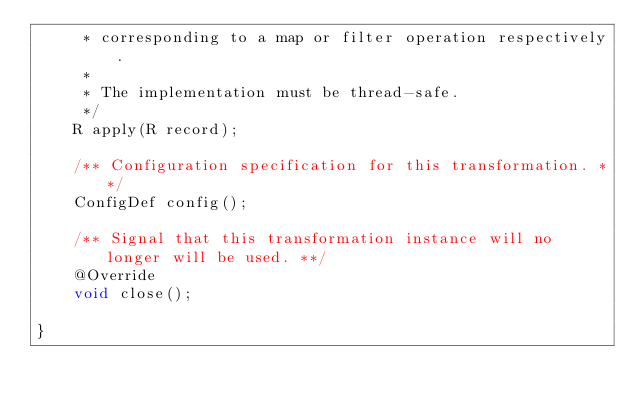Convert code to text. <code><loc_0><loc_0><loc_500><loc_500><_Java_>     * corresponding to a map or filter operation respectively.
     *
     * The implementation must be thread-safe.
     */
    R apply(R record);

    /** Configuration specification for this transformation. **/
    ConfigDef config();

    /** Signal that this transformation instance will no longer will be used. **/
    @Override
    void close();

}
</code> 